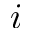Convert formula to latex. <formula><loc_0><loc_0><loc_500><loc_500>i</formula> 